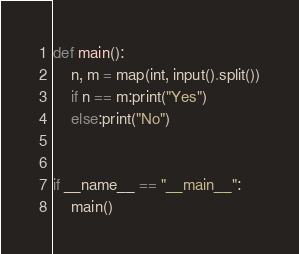<code> <loc_0><loc_0><loc_500><loc_500><_Python_>def main():
    n, m = map(int, input().split())
    if n == m:print("Yes")
    else:print("No")


if __name__ == "__main__":
    main()</code> 